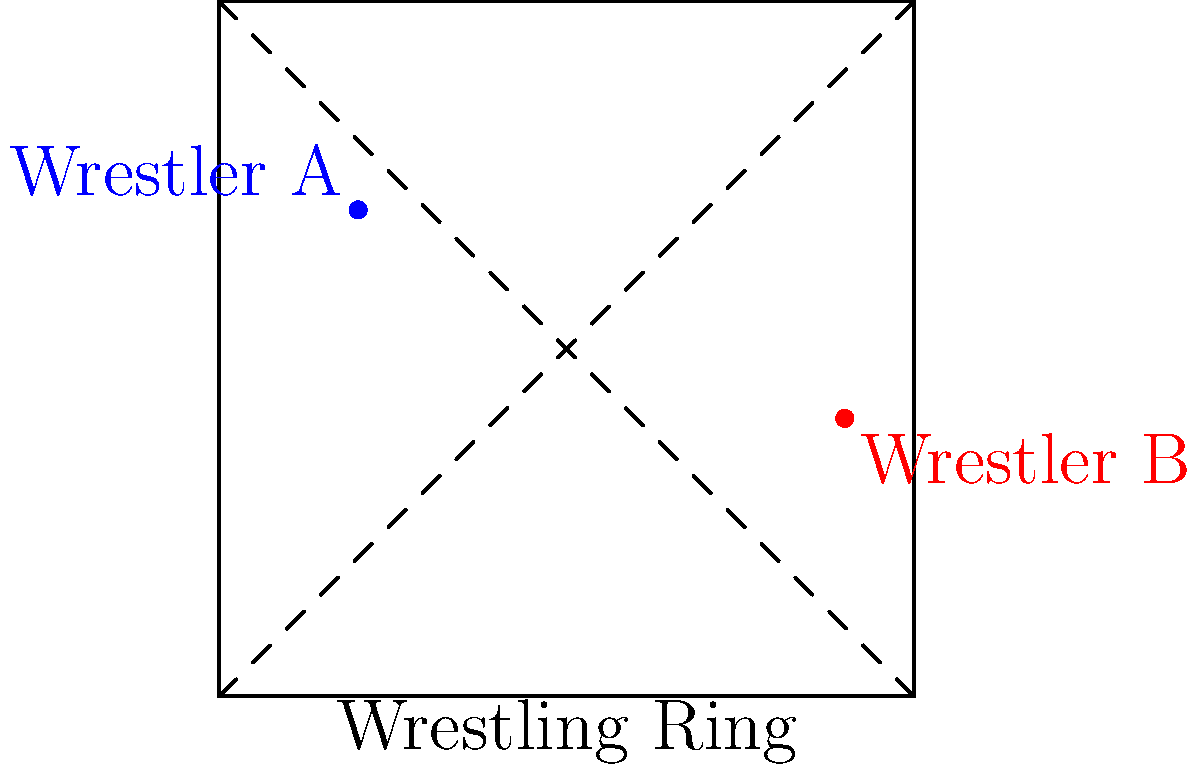In a wrestling ring represented by a coordinate plane, Wrestler A is positioned at $(-3, 2)$ and Wrestler B is at $(4, -1)$. What is the distance between the two wrestlers? To find the distance between two points on a coordinate plane, we can use the distance formula:

$d = \sqrt{(x_2 - x_1)^2 + (y_2 - y_1)^2}$

Where $(x_1, y_1)$ is the position of Wrestler A and $(x_2, y_2)$ is the position of Wrestler B.

Let's plug in the values:
$x_1 = -3, y_1 = 2$
$x_2 = 4, y_2 = -1$

Now, let's calculate step by step:

1) $d = \sqrt{(4 - (-3))^2 + (-1 - 2)^2}$

2) $d = \sqrt{(4 + 3)^2 + (-3)^2}$

3) $d = \sqrt{7^2 + (-3)^2}$

4) $d = \sqrt{49 + 9}$

5) $d = \sqrt{58}$

6) $d \approx 7.62$ (rounded to two decimal places)

Therefore, the distance between Wrestler A and Wrestler B is approximately 7.62 units.
Answer: $\sqrt{58}$ or approximately 7.62 units 